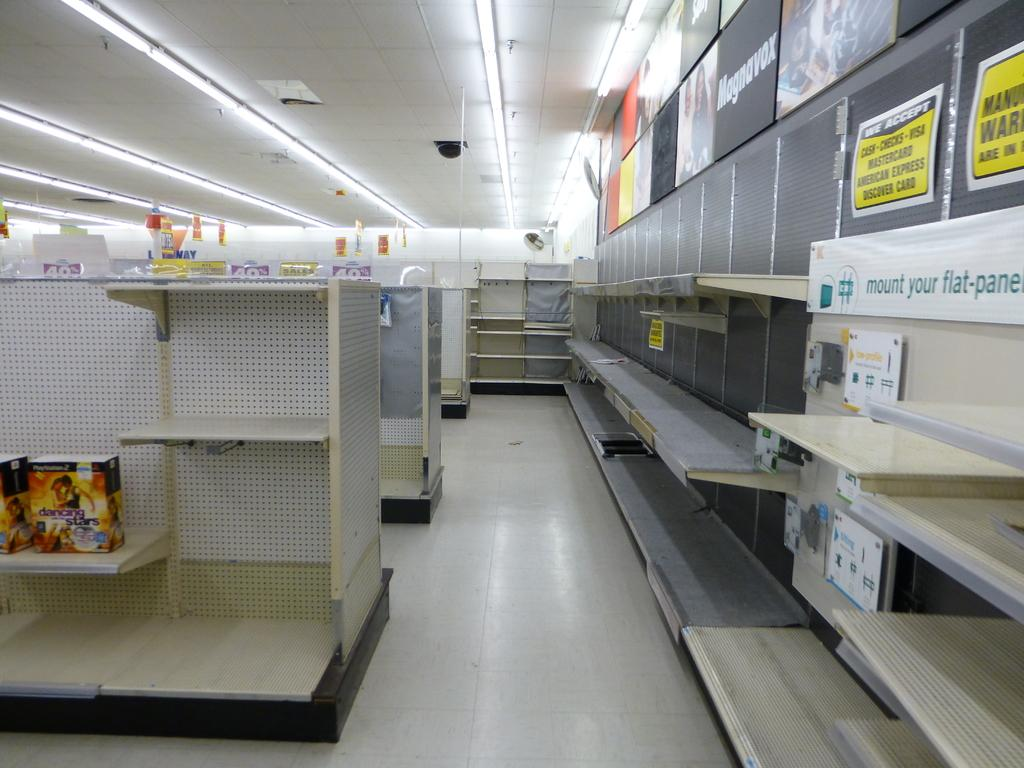What type of furniture is present in the image? There are cupboards in the image. What might be stored or displayed on or near the cupboards? Objects are placed on or near the cupboards. What type of decoration or signage is visible in the image? Banners are visible in the image. What type of lighting is present in the background of the image? Ceiling lights are present in the background of the image. How many bottles are visible on the cupboards in the image? There is no mention of bottles in the provided facts, so we cannot determine the number of bottles visible in the image. 